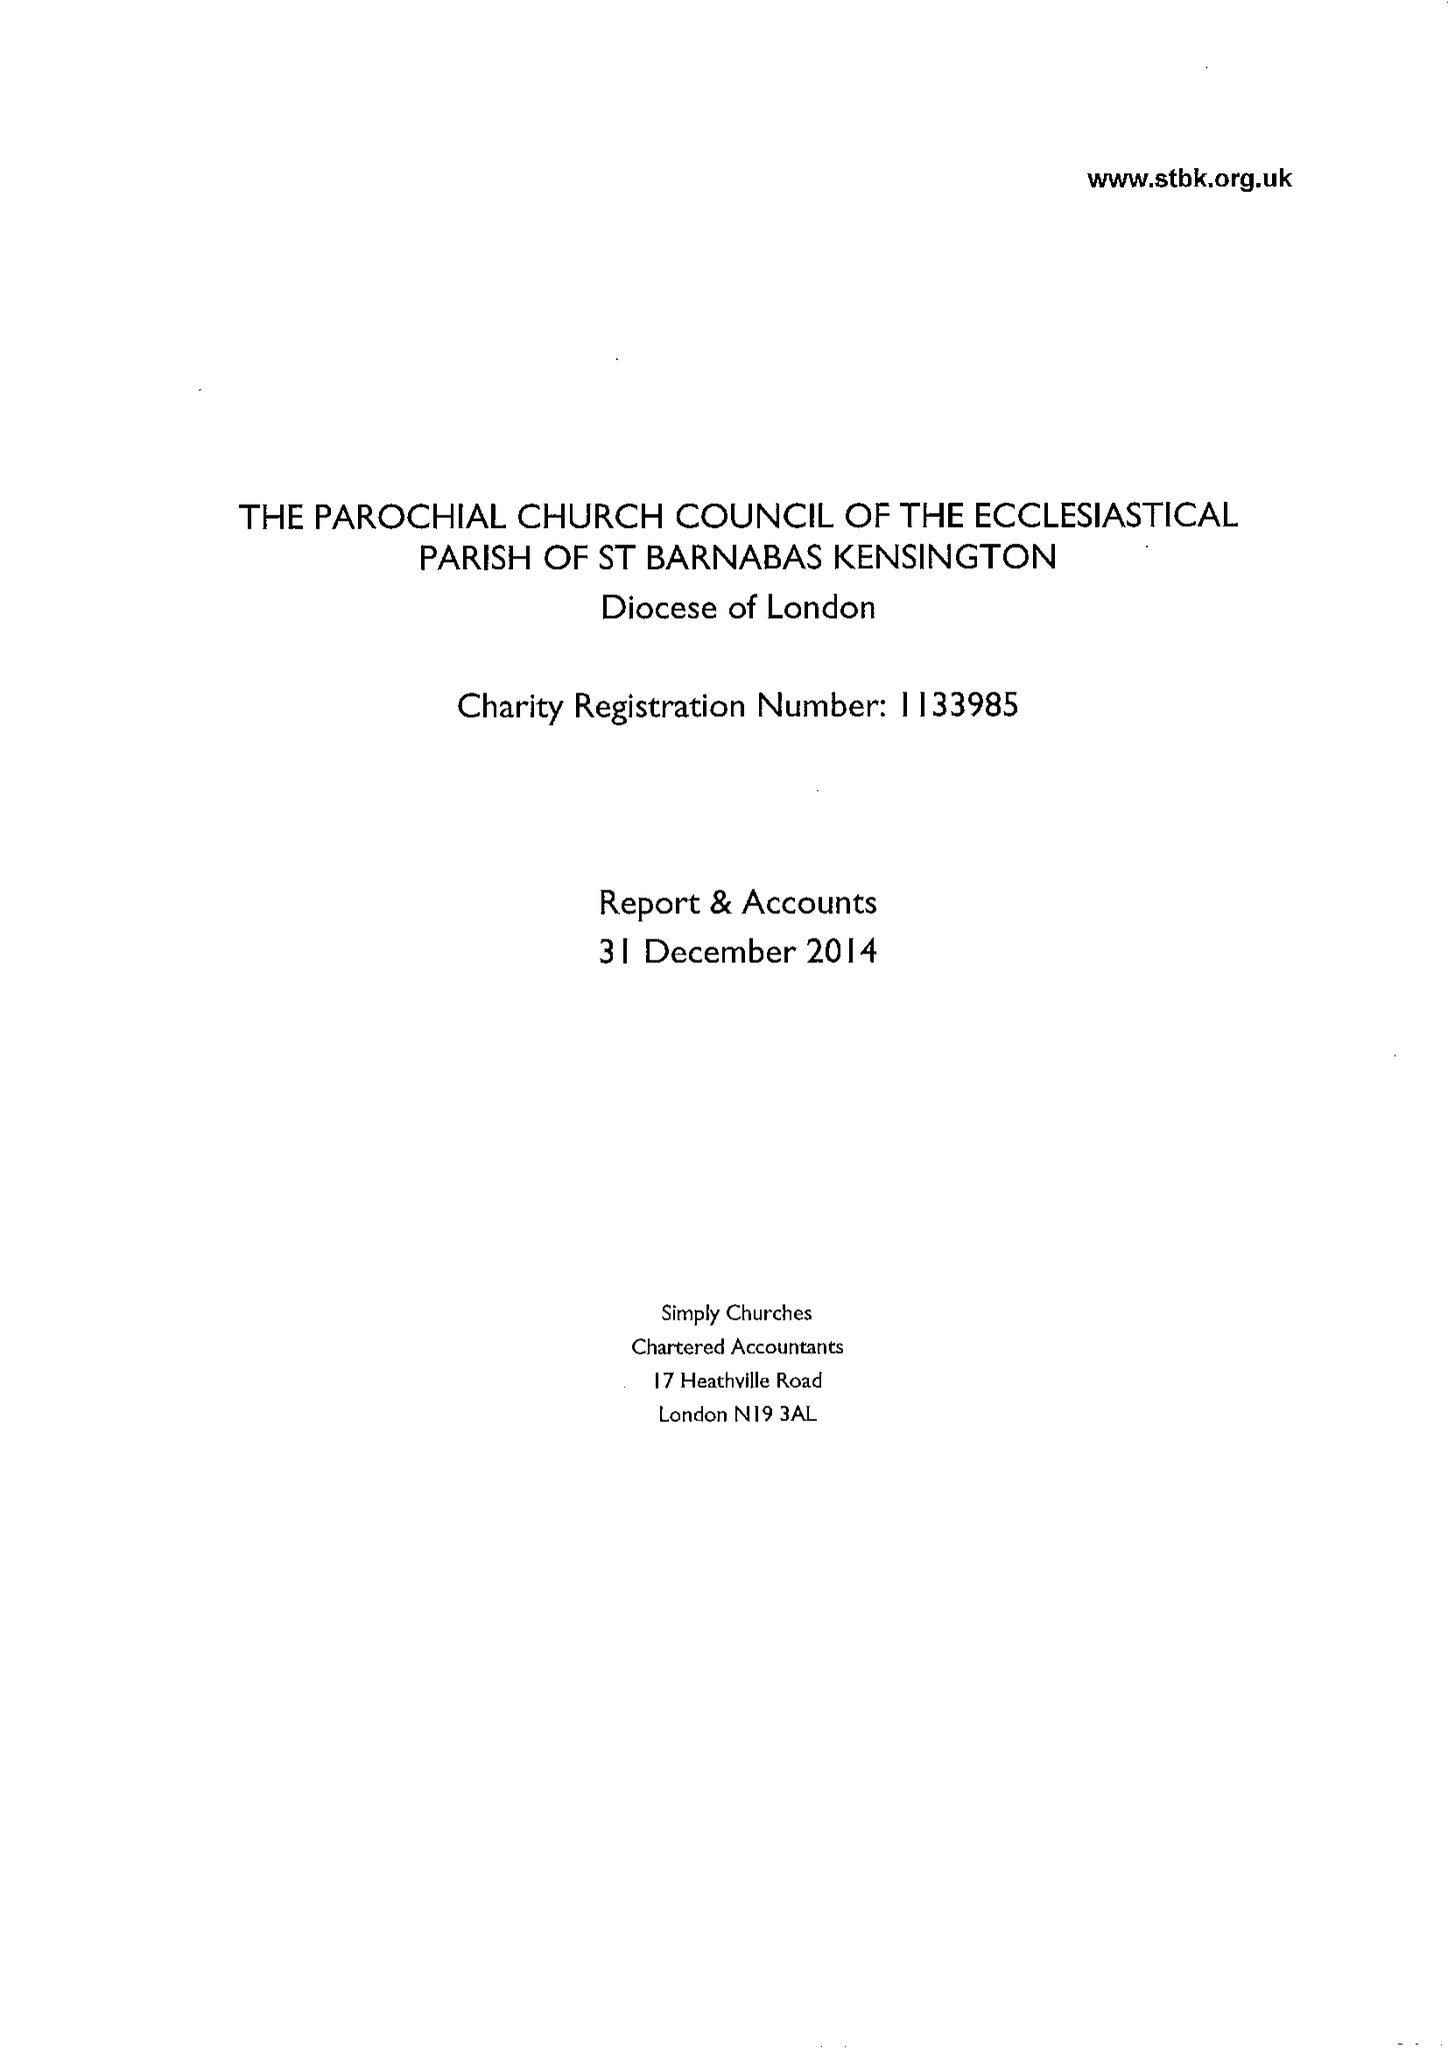What is the value for the charity_name?
Answer the question using a single word or phrase. The Parochial Church Council Of The Ecclesiastical Parish Of St Barnabas Kensington 